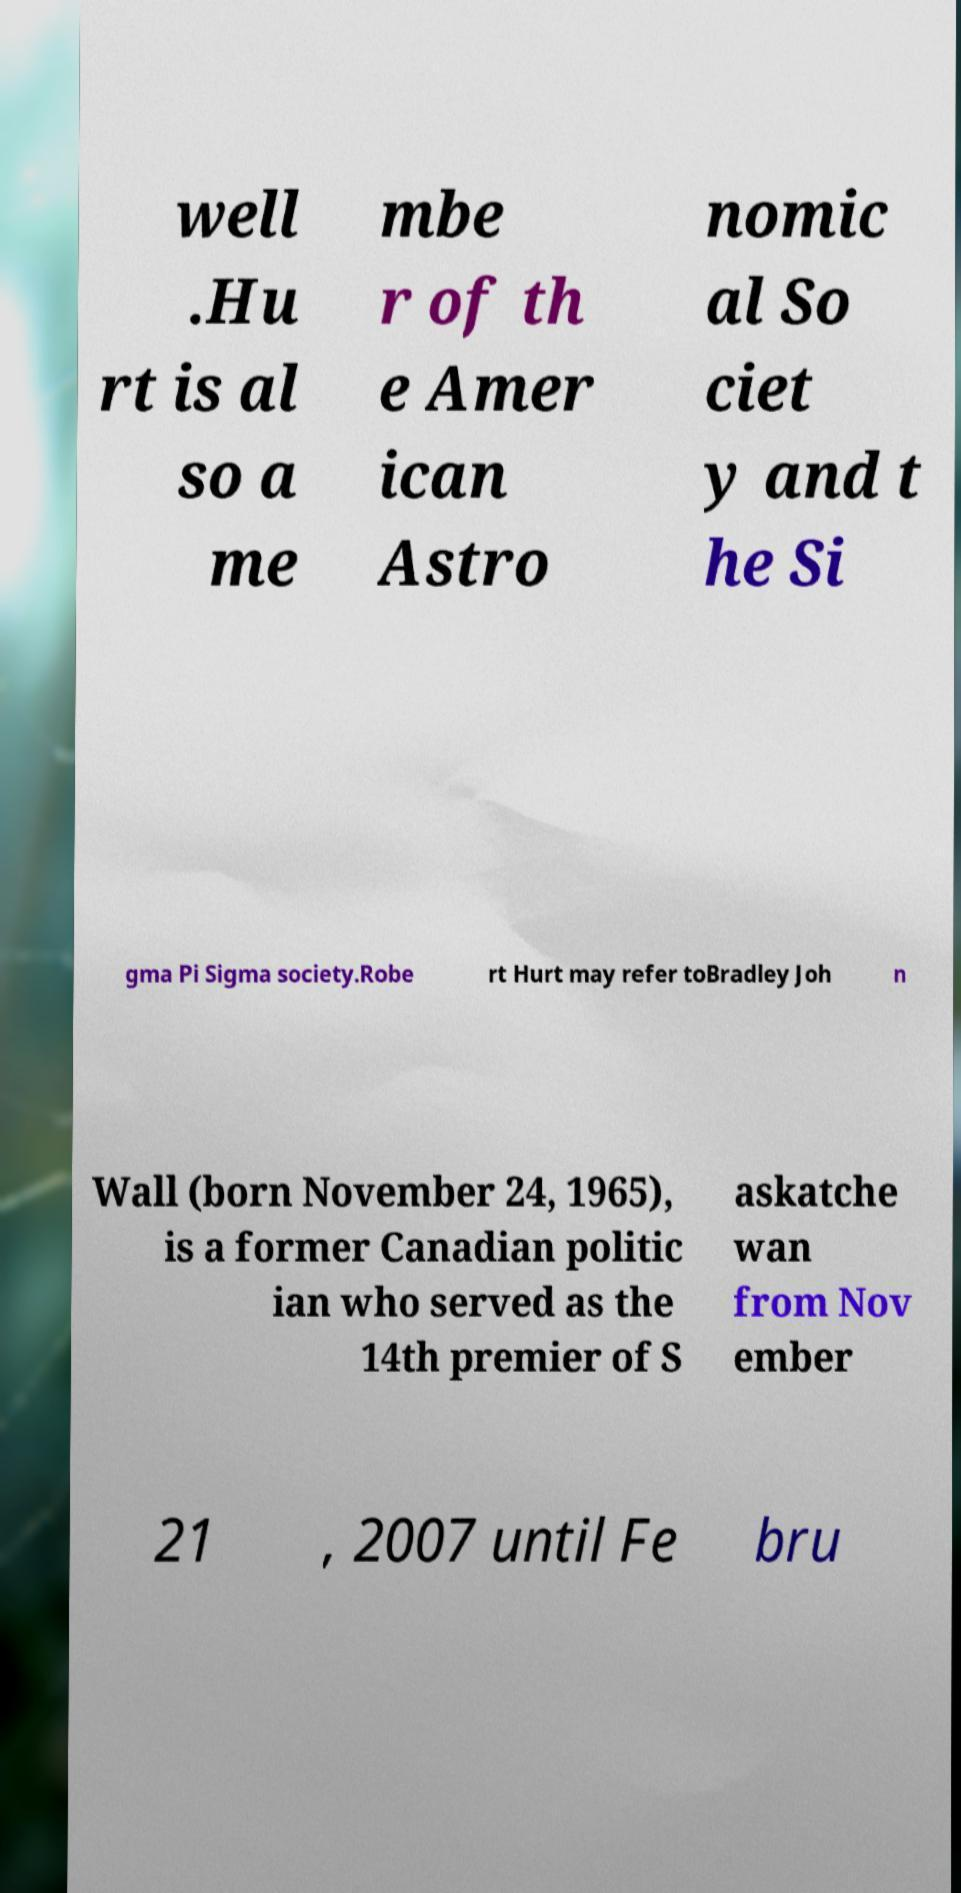What messages or text are displayed in this image? I need them in a readable, typed format. well .Hu rt is al so a me mbe r of th e Amer ican Astro nomic al So ciet y and t he Si gma Pi Sigma society.Robe rt Hurt may refer toBradley Joh n Wall (born November 24, 1965), is a former Canadian politic ian who served as the 14th premier of S askatche wan from Nov ember 21 , 2007 until Fe bru 